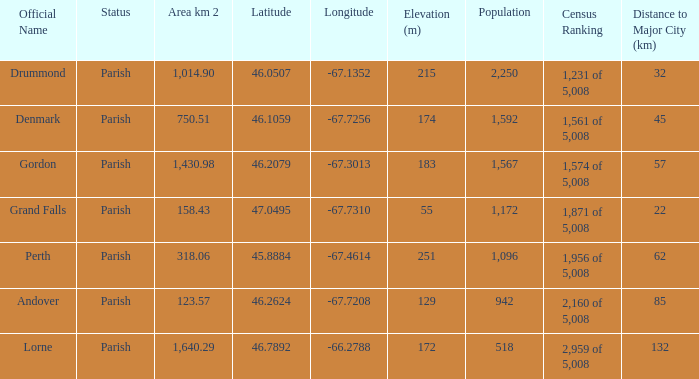What is the area of the parish with a population larger than 1,172 and a census ranking of 1,871 of 5,008? 0.0. 